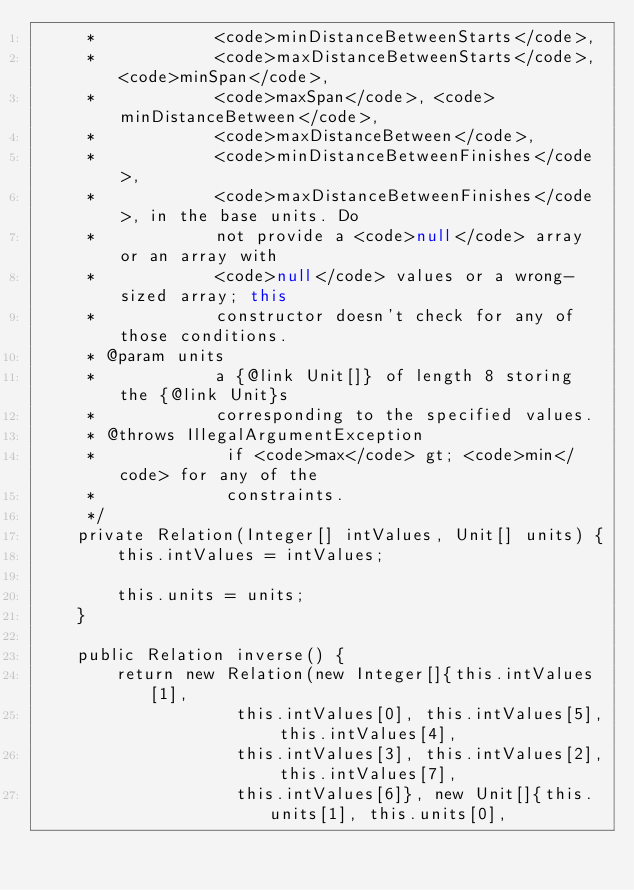<code> <loc_0><loc_0><loc_500><loc_500><_Java_>     *            <code>minDistanceBetweenStarts</code>,
     *            <code>maxDistanceBetweenStarts</code>, <code>minSpan</code>,
     *            <code>maxSpan</code>, <code>minDistanceBetween</code>,
     *            <code>maxDistanceBetween</code>,
     *            <code>minDistanceBetweenFinishes</code>,
     *            <code>maxDistanceBetweenFinishes</code>, in the base units. Do
     *            not provide a <code>null</code> array or an array with
     *            <code>null</code> values or a wrong-sized array; this
     *            constructor doesn't check for any of those conditions.
     * @param units
     *            a {@link Unit[]} of length 8 storing the {@link Unit}s
     *            corresponding to the specified values.
     * @throws IllegalArgumentException
     *             if <code>max</code> gt; <code>min</code> for any of the
     *             constraints.
     */
    private Relation(Integer[] intValues, Unit[] units) {
        this.intValues = intValues;

        this.units = units;
    }

    public Relation inverse() {
        return new Relation(new Integer[]{this.intValues[1],
                    this.intValues[0], this.intValues[5], this.intValues[4],
                    this.intValues[3], this.intValues[2], this.intValues[7],
                    this.intValues[6]}, new Unit[]{this.units[1], this.units[0],</code> 